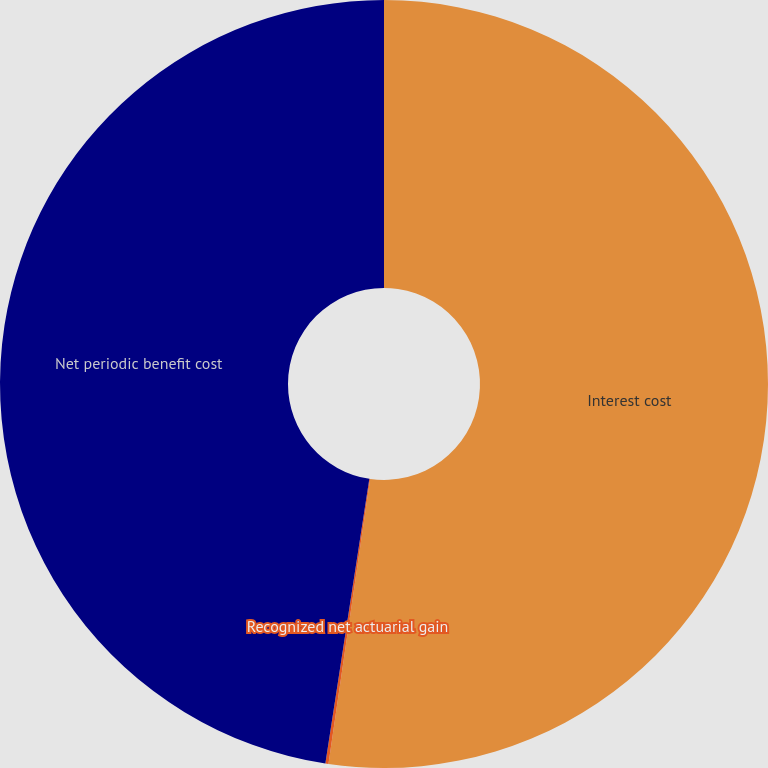<chart> <loc_0><loc_0><loc_500><loc_500><pie_chart><fcel>Interest cost<fcel>Recognized net actuarial gain<fcel>Net periodic benefit cost<nl><fcel>52.31%<fcel>0.13%<fcel>47.56%<nl></chart> 